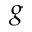Convert formula to latex. <formula><loc_0><loc_0><loc_500><loc_500>g</formula> 